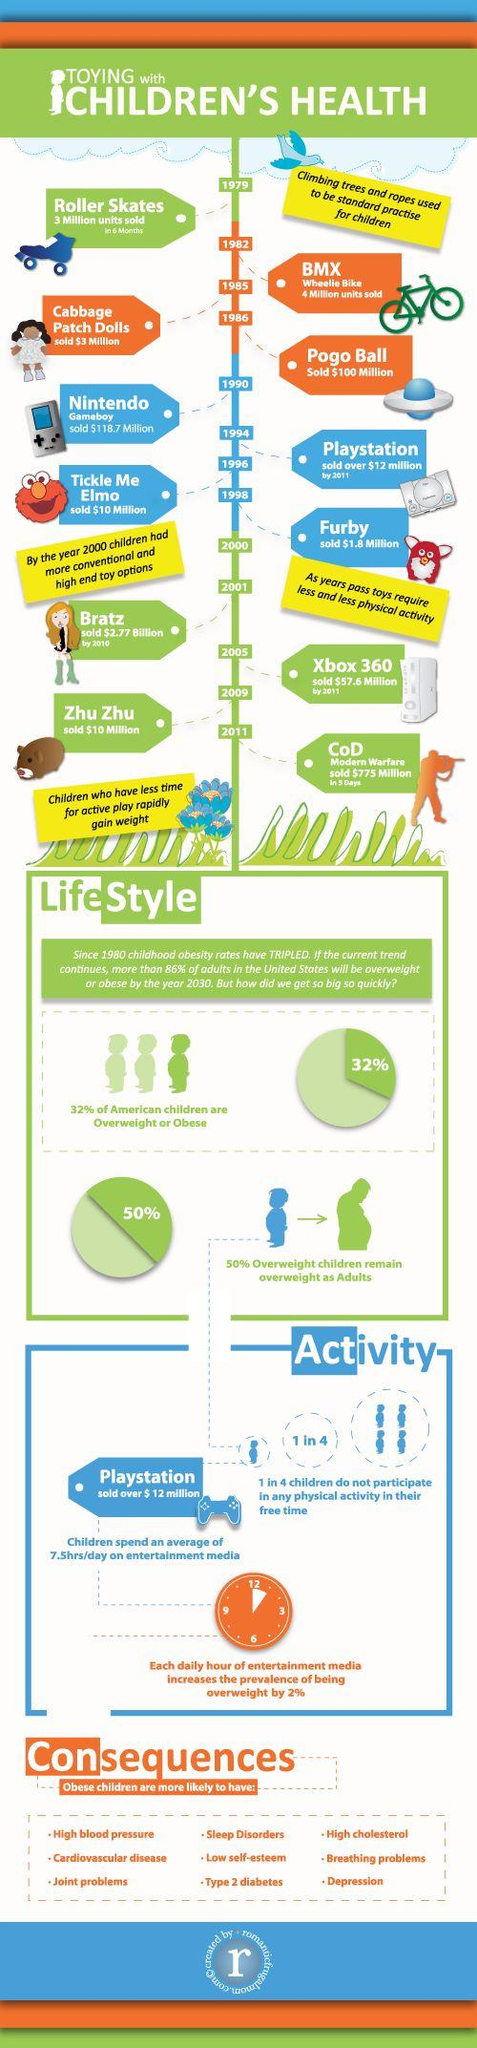Point out several critical features in this image. Furby is a popular toy that is sold for $1.8 million. According to recent statistics, 68% of American children are not overweight. Out of the 4 children surveyed, 3 participate in physical activity during their free time. 